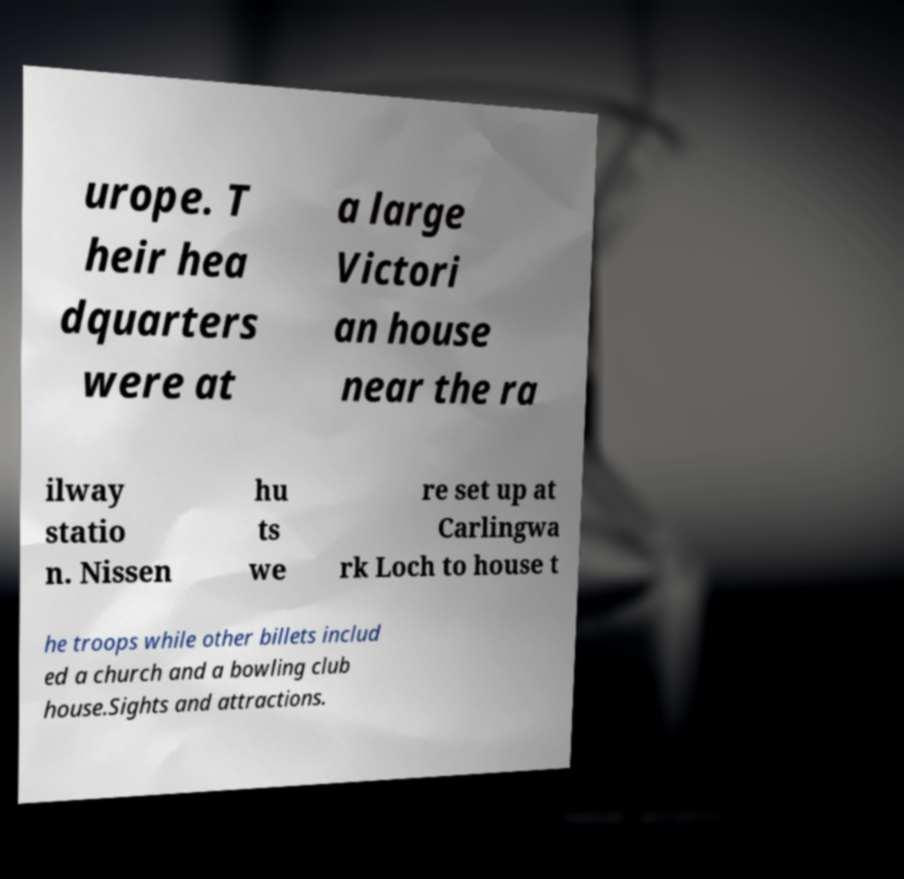Please identify and transcribe the text found in this image. urope. T heir hea dquarters were at a large Victori an house near the ra ilway statio n. Nissen hu ts we re set up at Carlingwa rk Loch to house t he troops while other billets includ ed a church and a bowling club house.Sights and attractions. 